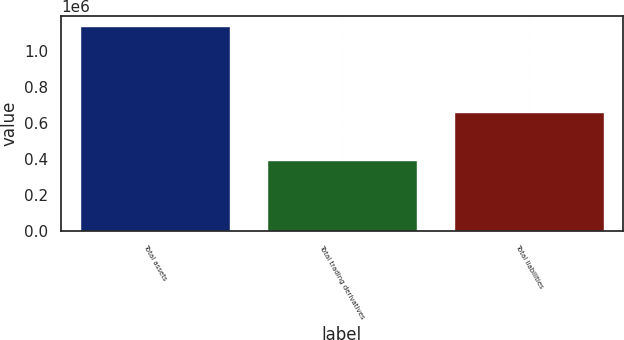Convert chart. <chart><loc_0><loc_0><loc_500><loc_500><bar_chart><fcel>Total assets<fcel>Total trading derivatives<fcel>Total liabilities<nl><fcel>1.13403e+06<fcel>392936<fcel>656892<nl></chart> 